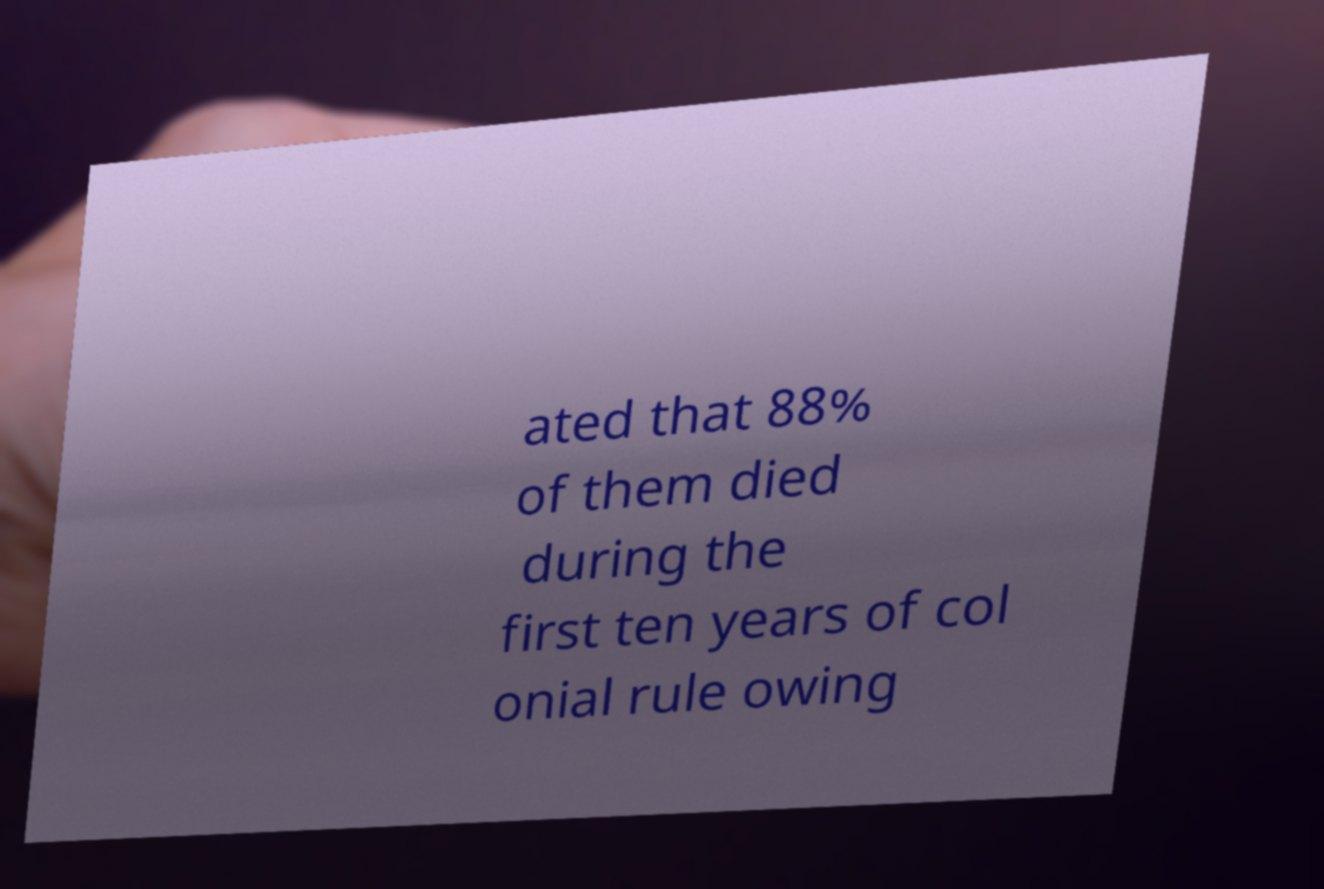Please identify and transcribe the text found in this image. ated that 88% of them died during the first ten years of col onial rule owing 